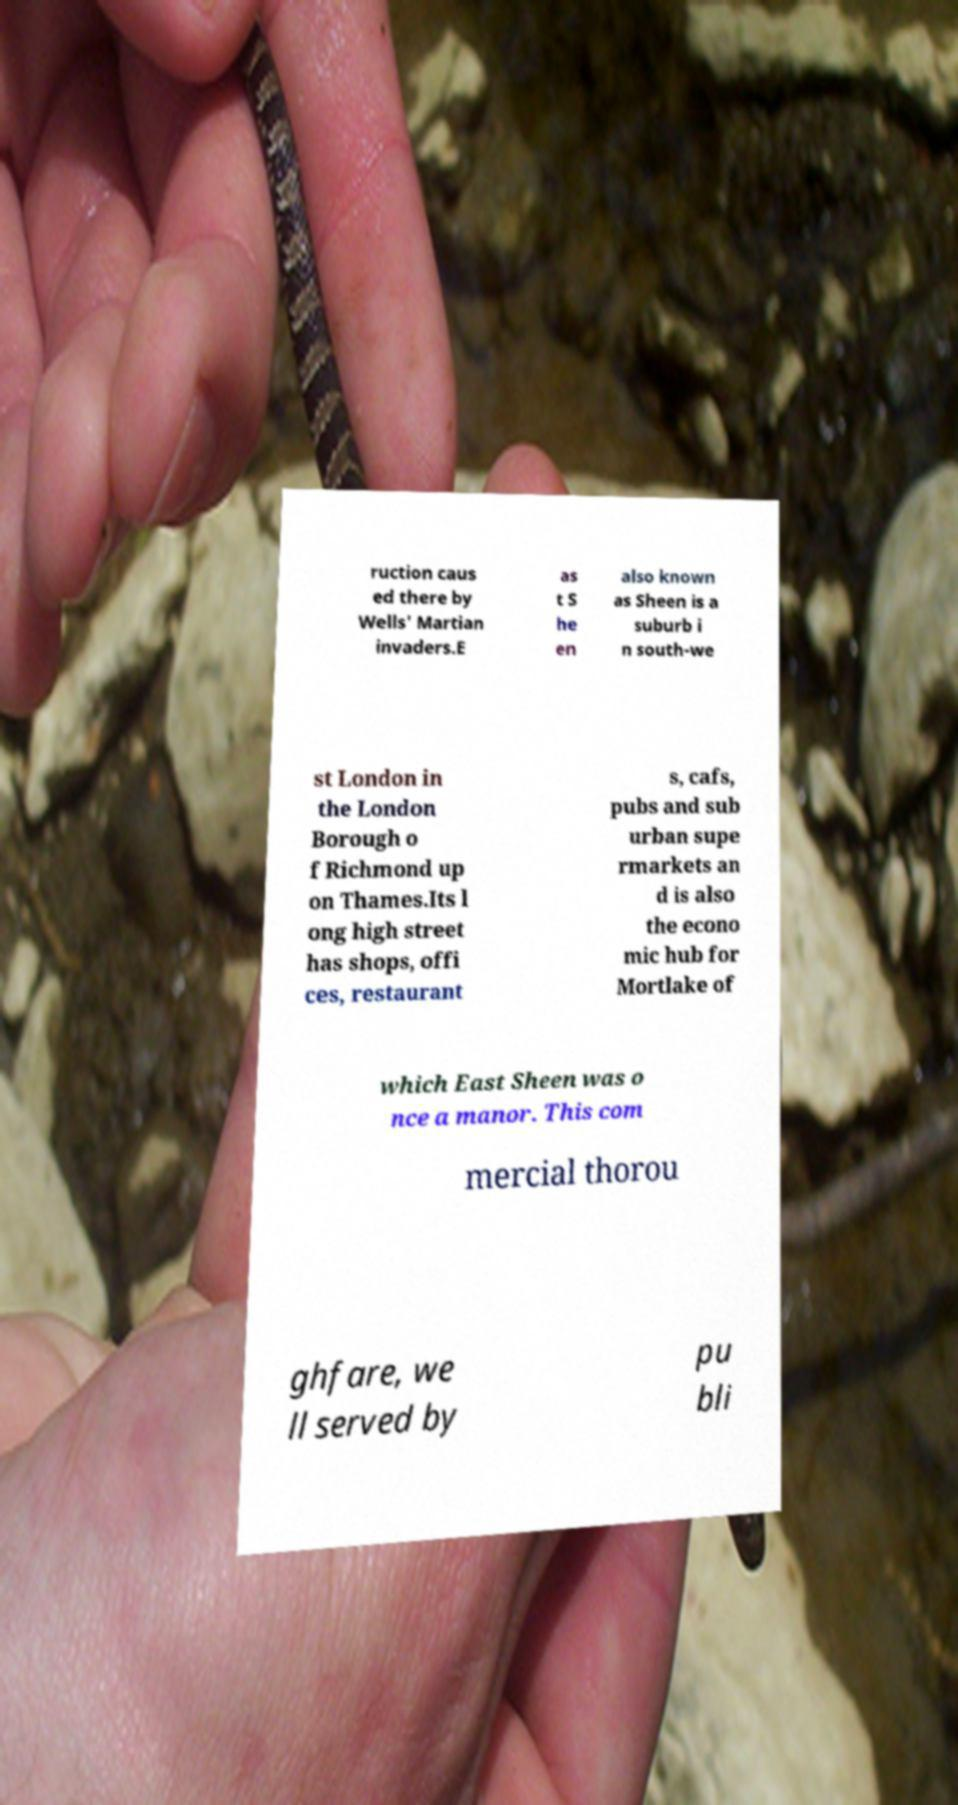Please identify and transcribe the text found in this image. ruction caus ed there by Wells' Martian invaders.E as t S he en also known as Sheen is a suburb i n south-we st London in the London Borough o f Richmond up on Thames.Its l ong high street has shops, offi ces, restaurant s, cafs, pubs and sub urban supe rmarkets an d is also the econo mic hub for Mortlake of which East Sheen was o nce a manor. This com mercial thorou ghfare, we ll served by pu bli 